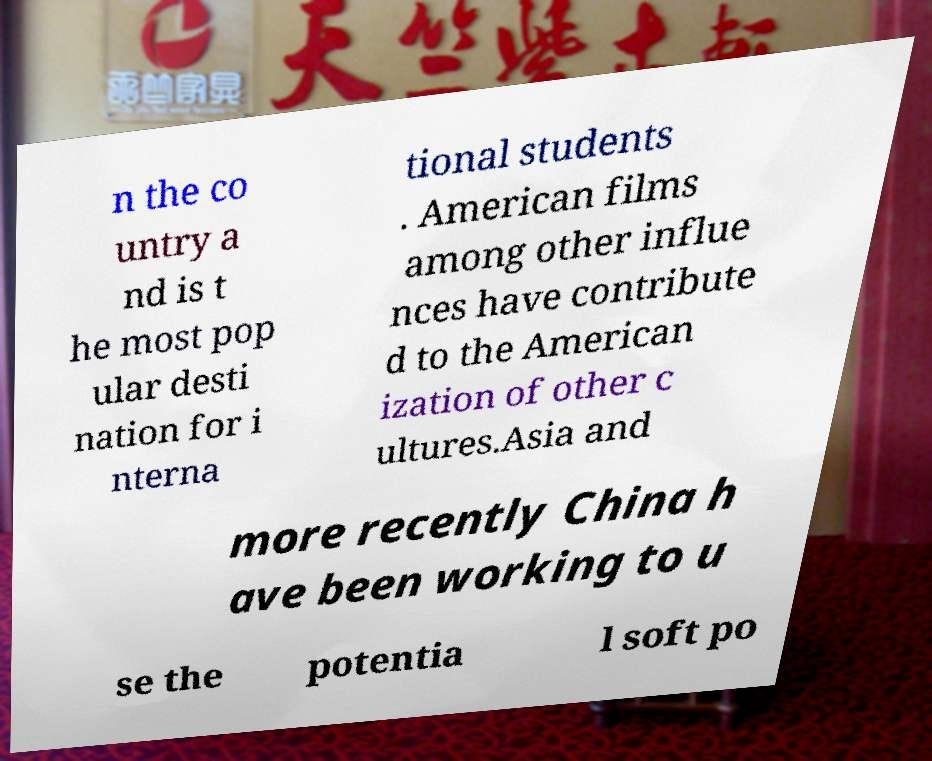Could you extract and type out the text from this image? n the co untry a nd is t he most pop ular desti nation for i nterna tional students . American films among other influe nces have contribute d to the American ization of other c ultures.Asia and more recently China h ave been working to u se the potentia l soft po 